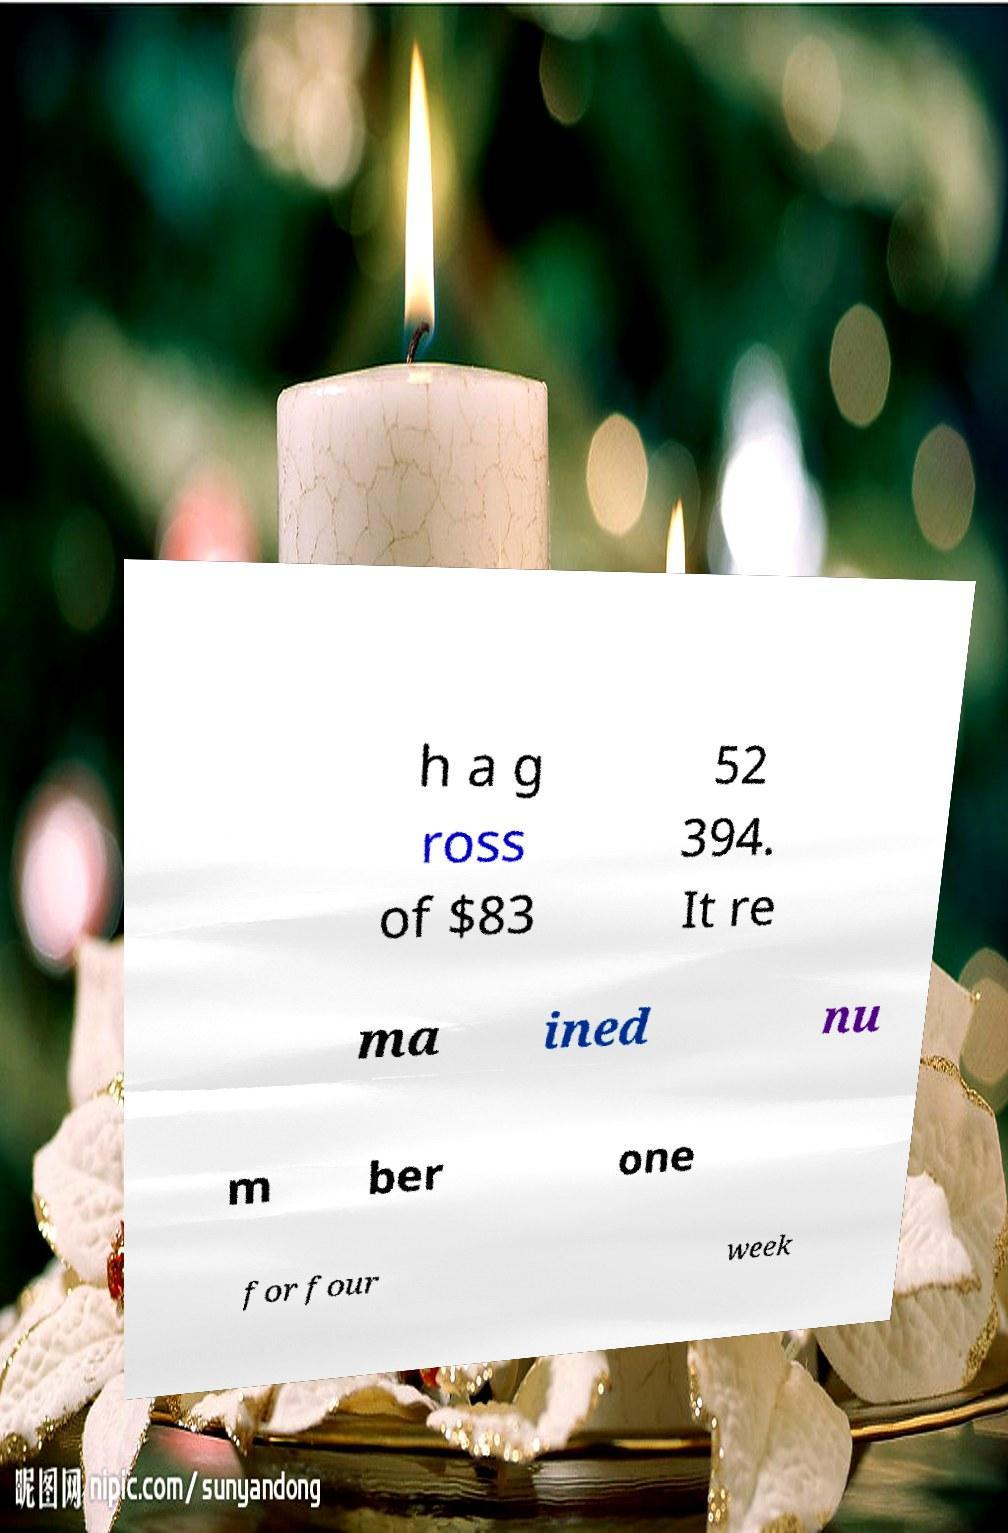There's text embedded in this image that I need extracted. Can you transcribe it verbatim? h a g ross of $83 52 394. It re ma ined nu m ber one for four week 